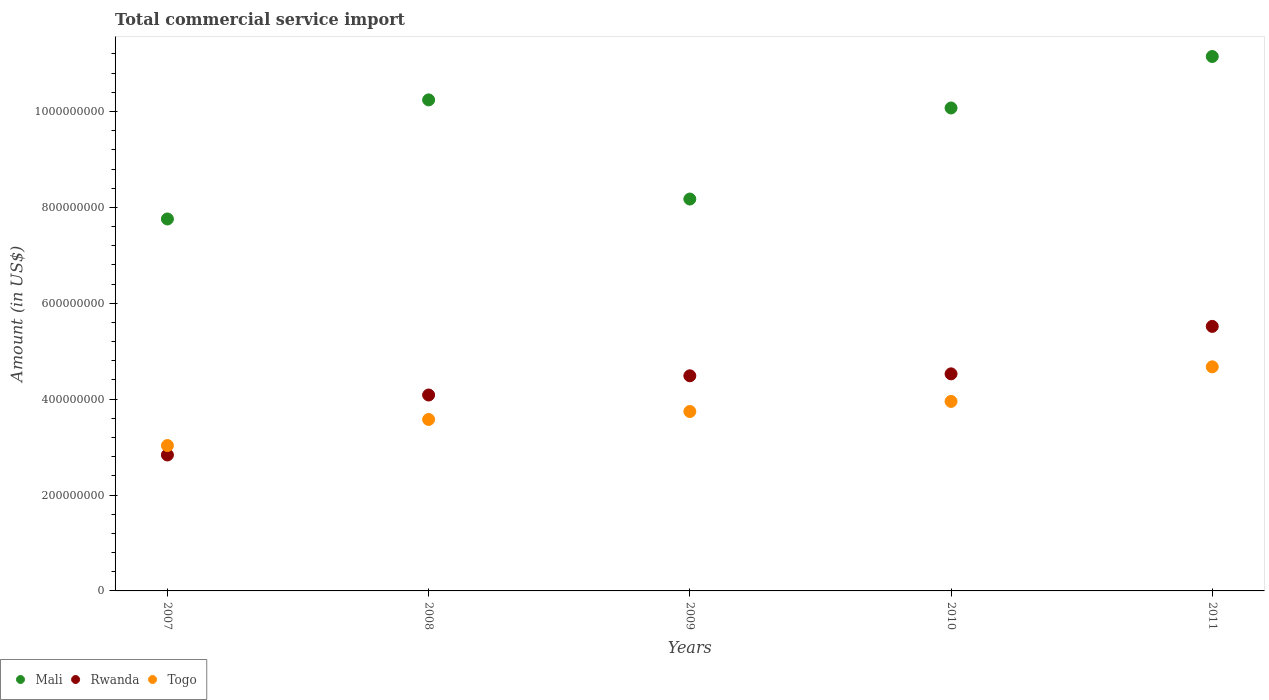Is the number of dotlines equal to the number of legend labels?
Make the answer very short. Yes. What is the total commercial service import in Rwanda in 2010?
Your answer should be compact. 4.53e+08. Across all years, what is the maximum total commercial service import in Mali?
Your answer should be compact. 1.11e+09. Across all years, what is the minimum total commercial service import in Rwanda?
Provide a succinct answer. 2.84e+08. In which year was the total commercial service import in Togo maximum?
Your answer should be very brief. 2011. In which year was the total commercial service import in Rwanda minimum?
Your answer should be compact. 2007. What is the total total commercial service import in Mali in the graph?
Give a very brief answer. 4.74e+09. What is the difference between the total commercial service import in Rwanda in 2009 and that in 2011?
Your response must be concise. -1.03e+08. What is the difference between the total commercial service import in Rwanda in 2010 and the total commercial service import in Togo in 2008?
Offer a very short reply. 9.51e+07. What is the average total commercial service import in Rwanda per year?
Your answer should be compact. 4.29e+08. In the year 2008, what is the difference between the total commercial service import in Rwanda and total commercial service import in Togo?
Keep it short and to the point. 5.10e+07. In how many years, is the total commercial service import in Mali greater than 1000000000 US$?
Offer a terse response. 3. What is the ratio of the total commercial service import in Mali in 2007 to that in 2008?
Provide a succinct answer. 0.76. What is the difference between the highest and the second highest total commercial service import in Togo?
Provide a short and direct response. 7.21e+07. What is the difference between the highest and the lowest total commercial service import in Togo?
Your response must be concise. 1.64e+08. In how many years, is the total commercial service import in Togo greater than the average total commercial service import in Togo taken over all years?
Provide a short and direct response. 2. Is it the case that in every year, the sum of the total commercial service import in Rwanda and total commercial service import in Mali  is greater than the total commercial service import in Togo?
Keep it short and to the point. Yes. How many years are there in the graph?
Your answer should be very brief. 5. What is the difference between two consecutive major ticks on the Y-axis?
Ensure brevity in your answer.  2.00e+08. Are the values on the major ticks of Y-axis written in scientific E-notation?
Ensure brevity in your answer.  No. Where does the legend appear in the graph?
Offer a very short reply. Bottom left. How are the legend labels stacked?
Your response must be concise. Horizontal. What is the title of the graph?
Offer a very short reply. Total commercial service import. What is the Amount (in US$) in Mali in 2007?
Provide a succinct answer. 7.76e+08. What is the Amount (in US$) of Rwanda in 2007?
Ensure brevity in your answer.  2.84e+08. What is the Amount (in US$) of Togo in 2007?
Ensure brevity in your answer.  3.03e+08. What is the Amount (in US$) in Mali in 2008?
Offer a terse response. 1.02e+09. What is the Amount (in US$) in Rwanda in 2008?
Offer a terse response. 4.09e+08. What is the Amount (in US$) in Togo in 2008?
Offer a very short reply. 3.58e+08. What is the Amount (in US$) of Mali in 2009?
Provide a short and direct response. 8.17e+08. What is the Amount (in US$) of Rwanda in 2009?
Your answer should be compact. 4.49e+08. What is the Amount (in US$) of Togo in 2009?
Keep it short and to the point. 3.74e+08. What is the Amount (in US$) in Mali in 2010?
Your response must be concise. 1.01e+09. What is the Amount (in US$) of Rwanda in 2010?
Offer a very short reply. 4.53e+08. What is the Amount (in US$) in Togo in 2010?
Offer a terse response. 3.95e+08. What is the Amount (in US$) of Mali in 2011?
Offer a terse response. 1.11e+09. What is the Amount (in US$) of Rwanda in 2011?
Offer a terse response. 5.52e+08. What is the Amount (in US$) in Togo in 2011?
Ensure brevity in your answer.  4.67e+08. Across all years, what is the maximum Amount (in US$) in Mali?
Ensure brevity in your answer.  1.11e+09. Across all years, what is the maximum Amount (in US$) in Rwanda?
Your response must be concise. 5.52e+08. Across all years, what is the maximum Amount (in US$) in Togo?
Keep it short and to the point. 4.67e+08. Across all years, what is the minimum Amount (in US$) in Mali?
Offer a very short reply. 7.76e+08. Across all years, what is the minimum Amount (in US$) in Rwanda?
Your answer should be compact. 2.84e+08. Across all years, what is the minimum Amount (in US$) of Togo?
Offer a very short reply. 3.03e+08. What is the total Amount (in US$) of Mali in the graph?
Your response must be concise. 4.74e+09. What is the total Amount (in US$) of Rwanda in the graph?
Your answer should be compact. 2.15e+09. What is the total Amount (in US$) of Togo in the graph?
Ensure brevity in your answer.  1.90e+09. What is the difference between the Amount (in US$) in Mali in 2007 and that in 2008?
Offer a terse response. -2.48e+08. What is the difference between the Amount (in US$) in Rwanda in 2007 and that in 2008?
Offer a terse response. -1.25e+08. What is the difference between the Amount (in US$) in Togo in 2007 and that in 2008?
Your response must be concise. -5.44e+07. What is the difference between the Amount (in US$) in Mali in 2007 and that in 2009?
Offer a very short reply. -4.16e+07. What is the difference between the Amount (in US$) of Rwanda in 2007 and that in 2009?
Provide a succinct answer. -1.65e+08. What is the difference between the Amount (in US$) in Togo in 2007 and that in 2009?
Offer a very short reply. -7.10e+07. What is the difference between the Amount (in US$) in Mali in 2007 and that in 2010?
Your answer should be very brief. -2.32e+08. What is the difference between the Amount (in US$) in Rwanda in 2007 and that in 2010?
Make the answer very short. -1.69e+08. What is the difference between the Amount (in US$) in Togo in 2007 and that in 2010?
Offer a terse response. -9.20e+07. What is the difference between the Amount (in US$) in Mali in 2007 and that in 2011?
Your answer should be very brief. -3.39e+08. What is the difference between the Amount (in US$) in Rwanda in 2007 and that in 2011?
Offer a terse response. -2.68e+08. What is the difference between the Amount (in US$) in Togo in 2007 and that in 2011?
Offer a terse response. -1.64e+08. What is the difference between the Amount (in US$) of Mali in 2008 and that in 2009?
Give a very brief answer. 2.07e+08. What is the difference between the Amount (in US$) of Rwanda in 2008 and that in 2009?
Keep it short and to the point. -4.01e+07. What is the difference between the Amount (in US$) of Togo in 2008 and that in 2009?
Provide a short and direct response. -1.66e+07. What is the difference between the Amount (in US$) of Mali in 2008 and that in 2010?
Give a very brief answer. 1.69e+07. What is the difference between the Amount (in US$) in Rwanda in 2008 and that in 2010?
Provide a short and direct response. -4.41e+07. What is the difference between the Amount (in US$) of Togo in 2008 and that in 2010?
Offer a terse response. -3.77e+07. What is the difference between the Amount (in US$) in Mali in 2008 and that in 2011?
Provide a succinct answer. -9.05e+07. What is the difference between the Amount (in US$) in Rwanda in 2008 and that in 2011?
Your response must be concise. -1.43e+08. What is the difference between the Amount (in US$) in Togo in 2008 and that in 2011?
Your answer should be very brief. -1.10e+08. What is the difference between the Amount (in US$) of Mali in 2009 and that in 2010?
Provide a short and direct response. -1.90e+08. What is the difference between the Amount (in US$) of Rwanda in 2009 and that in 2010?
Provide a short and direct response. -4.07e+06. What is the difference between the Amount (in US$) of Togo in 2009 and that in 2010?
Give a very brief answer. -2.11e+07. What is the difference between the Amount (in US$) in Mali in 2009 and that in 2011?
Make the answer very short. -2.97e+08. What is the difference between the Amount (in US$) in Rwanda in 2009 and that in 2011?
Your answer should be compact. -1.03e+08. What is the difference between the Amount (in US$) in Togo in 2009 and that in 2011?
Your response must be concise. -9.32e+07. What is the difference between the Amount (in US$) of Mali in 2010 and that in 2011?
Give a very brief answer. -1.07e+08. What is the difference between the Amount (in US$) in Rwanda in 2010 and that in 2011?
Offer a very short reply. -9.90e+07. What is the difference between the Amount (in US$) of Togo in 2010 and that in 2011?
Offer a terse response. -7.21e+07. What is the difference between the Amount (in US$) of Mali in 2007 and the Amount (in US$) of Rwanda in 2008?
Give a very brief answer. 3.67e+08. What is the difference between the Amount (in US$) in Mali in 2007 and the Amount (in US$) in Togo in 2008?
Your response must be concise. 4.18e+08. What is the difference between the Amount (in US$) of Rwanda in 2007 and the Amount (in US$) of Togo in 2008?
Your response must be concise. -7.40e+07. What is the difference between the Amount (in US$) in Mali in 2007 and the Amount (in US$) in Rwanda in 2009?
Provide a succinct answer. 3.27e+08. What is the difference between the Amount (in US$) in Mali in 2007 and the Amount (in US$) in Togo in 2009?
Your response must be concise. 4.02e+08. What is the difference between the Amount (in US$) in Rwanda in 2007 and the Amount (in US$) in Togo in 2009?
Give a very brief answer. -9.06e+07. What is the difference between the Amount (in US$) of Mali in 2007 and the Amount (in US$) of Rwanda in 2010?
Your response must be concise. 3.23e+08. What is the difference between the Amount (in US$) of Mali in 2007 and the Amount (in US$) of Togo in 2010?
Keep it short and to the point. 3.81e+08. What is the difference between the Amount (in US$) of Rwanda in 2007 and the Amount (in US$) of Togo in 2010?
Keep it short and to the point. -1.12e+08. What is the difference between the Amount (in US$) in Mali in 2007 and the Amount (in US$) in Rwanda in 2011?
Make the answer very short. 2.24e+08. What is the difference between the Amount (in US$) of Mali in 2007 and the Amount (in US$) of Togo in 2011?
Your answer should be compact. 3.08e+08. What is the difference between the Amount (in US$) of Rwanda in 2007 and the Amount (in US$) of Togo in 2011?
Your answer should be very brief. -1.84e+08. What is the difference between the Amount (in US$) in Mali in 2008 and the Amount (in US$) in Rwanda in 2009?
Offer a very short reply. 5.76e+08. What is the difference between the Amount (in US$) of Mali in 2008 and the Amount (in US$) of Togo in 2009?
Give a very brief answer. 6.50e+08. What is the difference between the Amount (in US$) of Rwanda in 2008 and the Amount (in US$) of Togo in 2009?
Keep it short and to the point. 3.44e+07. What is the difference between the Amount (in US$) of Mali in 2008 and the Amount (in US$) of Rwanda in 2010?
Provide a succinct answer. 5.71e+08. What is the difference between the Amount (in US$) of Mali in 2008 and the Amount (in US$) of Togo in 2010?
Offer a terse response. 6.29e+08. What is the difference between the Amount (in US$) of Rwanda in 2008 and the Amount (in US$) of Togo in 2010?
Your answer should be compact. 1.33e+07. What is the difference between the Amount (in US$) of Mali in 2008 and the Amount (in US$) of Rwanda in 2011?
Your answer should be compact. 4.72e+08. What is the difference between the Amount (in US$) of Mali in 2008 and the Amount (in US$) of Togo in 2011?
Keep it short and to the point. 5.57e+08. What is the difference between the Amount (in US$) of Rwanda in 2008 and the Amount (in US$) of Togo in 2011?
Offer a very short reply. -5.88e+07. What is the difference between the Amount (in US$) in Mali in 2009 and the Amount (in US$) in Rwanda in 2010?
Your answer should be compact. 3.65e+08. What is the difference between the Amount (in US$) in Mali in 2009 and the Amount (in US$) in Togo in 2010?
Your response must be concise. 4.22e+08. What is the difference between the Amount (in US$) of Rwanda in 2009 and the Amount (in US$) of Togo in 2010?
Offer a very short reply. 5.34e+07. What is the difference between the Amount (in US$) of Mali in 2009 and the Amount (in US$) of Rwanda in 2011?
Ensure brevity in your answer.  2.66e+08. What is the difference between the Amount (in US$) of Mali in 2009 and the Amount (in US$) of Togo in 2011?
Your answer should be very brief. 3.50e+08. What is the difference between the Amount (in US$) of Rwanda in 2009 and the Amount (in US$) of Togo in 2011?
Your answer should be very brief. -1.87e+07. What is the difference between the Amount (in US$) in Mali in 2010 and the Amount (in US$) in Rwanda in 2011?
Provide a succinct answer. 4.56e+08. What is the difference between the Amount (in US$) of Mali in 2010 and the Amount (in US$) of Togo in 2011?
Your answer should be very brief. 5.40e+08. What is the difference between the Amount (in US$) of Rwanda in 2010 and the Amount (in US$) of Togo in 2011?
Ensure brevity in your answer.  -1.47e+07. What is the average Amount (in US$) in Mali per year?
Your response must be concise. 9.48e+08. What is the average Amount (in US$) in Rwanda per year?
Provide a succinct answer. 4.29e+08. What is the average Amount (in US$) in Togo per year?
Offer a terse response. 3.80e+08. In the year 2007, what is the difference between the Amount (in US$) in Mali and Amount (in US$) in Rwanda?
Make the answer very short. 4.92e+08. In the year 2007, what is the difference between the Amount (in US$) of Mali and Amount (in US$) of Togo?
Provide a short and direct response. 4.73e+08. In the year 2007, what is the difference between the Amount (in US$) in Rwanda and Amount (in US$) in Togo?
Provide a succinct answer. -1.96e+07. In the year 2008, what is the difference between the Amount (in US$) in Mali and Amount (in US$) in Rwanda?
Ensure brevity in your answer.  6.16e+08. In the year 2008, what is the difference between the Amount (in US$) in Mali and Amount (in US$) in Togo?
Your response must be concise. 6.67e+08. In the year 2008, what is the difference between the Amount (in US$) in Rwanda and Amount (in US$) in Togo?
Your answer should be compact. 5.10e+07. In the year 2009, what is the difference between the Amount (in US$) in Mali and Amount (in US$) in Rwanda?
Provide a succinct answer. 3.69e+08. In the year 2009, what is the difference between the Amount (in US$) in Mali and Amount (in US$) in Togo?
Provide a short and direct response. 4.43e+08. In the year 2009, what is the difference between the Amount (in US$) of Rwanda and Amount (in US$) of Togo?
Give a very brief answer. 7.45e+07. In the year 2010, what is the difference between the Amount (in US$) of Mali and Amount (in US$) of Rwanda?
Keep it short and to the point. 5.55e+08. In the year 2010, what is the difference between the Amount (in US$) in Mali and Amount (in US$) in Togo?
Provide a succinct answer. 6.12e+08. In the year 2010, what is the difference between the Amount (in US$) in Rwanda and Amount (in US$) in Togo?
Give a very brief answer. 5.75e+07. In the year 2011, what is the difference between the Amount (in US$) in Mali and Amount (in US$) in Rwanda?
Keep it short and to the point. 5.63e+08. In the year 2011, what is the difference between the Amount (in US$) of Mali and Amount (in US$) of Togo?
Your answer should be very brief. 6.47e+08. In the year 2011, what is the difference between the Amount (in US$) of Rwanda and Amount (in US$) of Togo?
Ensure brevity in your answer.  8.43e+07. What is the ratio of the Amount (in US$) in Mali in 2007 to that in 2008?
Your response must be concise. 0.76. What is the ratio of the Amount (in US$) of Rwanda in 2007 to that in 2008?
Your answer should be very brief. 0.69. What is the ratio of the Amount (in US$) of Togo in 2007 to that in 2008?
Give a very brief answer. 0.85. What is the ratio of the Amount (in US$) of Mali in 2007 to that in 2009?
Offer a very short reply. 0.95. What is the ratio of the Amount (in US$) in Rwanda in 2007 to that in 2009?
Give a very brief answer. 0.63. What is the ratio of the Amount (in US$) of Togo in 2007 to that in 2009?
Provide a succinct answer. 0.81. What is the ratio of the Amount (in US$) of Mali in 2007 to that in 2010?
Your response must be concise. 0.77. What is the ratio of the Amount (in US$) in Rwanda in 2007 to that in 2010?
Offer a very short reply. 0.63. What is the ratio of the Amount (in US$) of Togo in 2007 to that in 2010?
Give a very brief answer. 0.77. What is the ratio of the Amount (in US$) in Mali in 2007 to that in 2011?
Provide a succinct answer. 0.7. What is the ratio of the Amount (in US$) of Rwanda in 2007 to that in 2011?
Your answer should be compact. 0.51. What is the ratio of the Amount (in US$) of Togo in 2007 to that in 2011?
Your response must be concise. 0.65. What is the ratio of the Amount (in US$) in Mali in 2008 to that in 2009?
Make the answer very short. 1.25. What is the ratio of the Amount (in US$) of Rwanda in 2008 to that in 2009?
Make the answer very short. 0.91. What is the ratio of the Amount (in US$) in Togo in 2008 to that in 2009?
Your response must be concise. 0.96. What is the ratio of the Amount (in US$) of Mali in 2008 to that in 2010?
Provide a short and direct response. 1.02. What is the ratio of the Amount (in US$) of Rwanda in 2008 to that in 2010?
Offer a terse response. 0.9. What is the ratio of the Amount (in US$) in Togo in 2008 to that in 2010?
Provide a short and direct response. 0.9. What is the ratio of the Amount (in US$) of Mali in 2008 to that in 2011?
Offer a very short reply. 0.92. What is the ratio of the Amount (in US$) of Rwanda in 2008 to that in 2011?
Keep it short and to the point. 0.74. What is the ratio of the Amount (in US$) of Togo in 2008 to that in 2011?
Your answer should be very brief. 0.77. What is the ratio of the Amount (in US$) in Mali in 2009 to that in 2010?
Provide a succinct answer. 0.81. What is the ratio of the Amount (in US$) in Rwanda in 2009 to that in 2010?
Make the answer very short. 0.99. What is the ratio of the Amount (in US$) in Togo in 2009 to that in 2010?
Your answer should be very brief. 0.95. What is the ratio of the Amount (in US$) of Mali in 2009 to that in 2011?
Offer a terse response. 0.73. What is the ratio of the Amount (in US$) of Rwanda in 2009 to that in 2011?
Keep it short and to the point. 0.81. What is the ratio of the Amount (in US$) in Togo in 2009 to that in 2011?
Your response must be concise. 0.8. What is the ratio of the Amount (in US$) of Mali in 2010 to that in 2011?
Offer a terse response. 0.9. What is the ratio of the Amount (in US$) in Rwanda in 2010 to that in 2011?
Your response must be concise. 0.82. What is the ratio of the Amount (in US$) in Togo in 2010 to that in 2011?
Offer a very short reply. 0.85. What is the difference between the highest and the second highest Amount (in US$) in Mali?
Your response must be concise. 9.05e+07. What is the difference between the highest and the second highest Amount (in US$) of Rwanda?
Provide a short and direct response. 9.90e+07. What is the difference between the highest and the second highest Amount (in US$) in Togo?
Keep it short and to the point. 7.21e+07. What is the difference between the highest and the lowest Amount (in US$) in Mali?
Your answer should be compact. 3.39e+08. What is the difference between the highest and the lowest Amount (in US$) of Rwanda?
Ensure brevity in your answer.  2.68e+08. What is the difference between the highest and the lowest Amount (in US$) in Togo?
Give a very brief answer. 1.64e+08. 